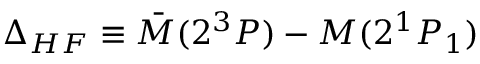<formula> <loc_0><loc_0><loc_500><loc_500>\Delta _ { H F } \equiv \bar { M } ( 2 ^ { 3 } P ) - M ( 2 ^ { 1 } P _ { 1 } )</formula> 